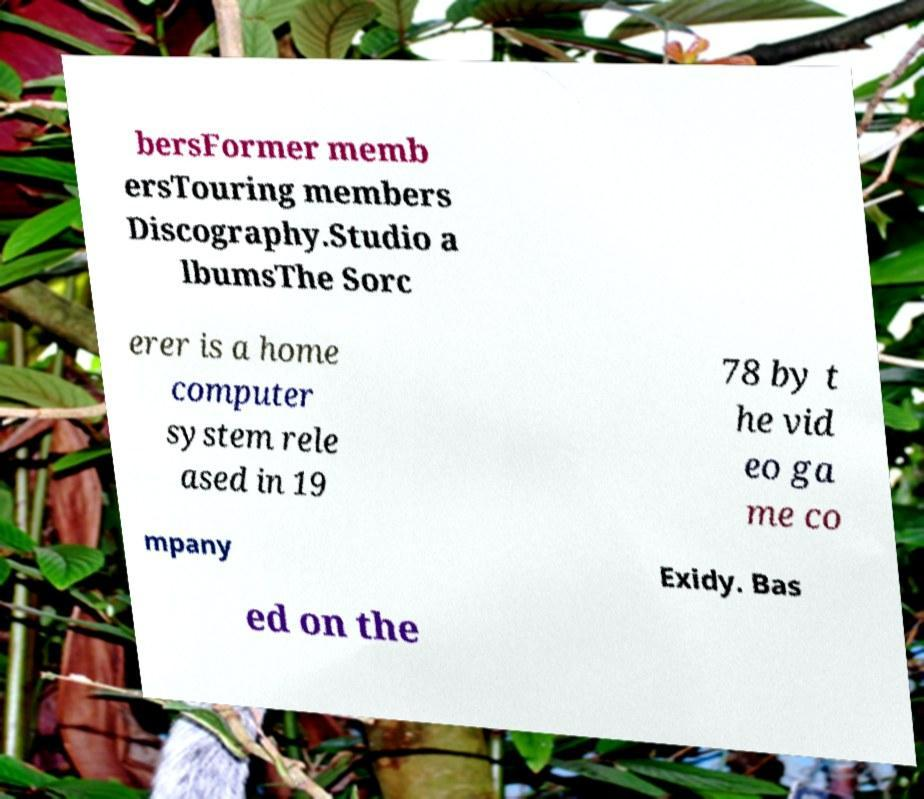Can you read and provide the text displayed in the image?This photo seems to have some interesting text. Can you extract and type it out for me? bersFormer memb ersTouring members Discography.Studio a lbumsThe Sorc erer is a home computer system rele ased in 19 78 by t he vid eo ga me co mpany Exidy. Bas ed on the 